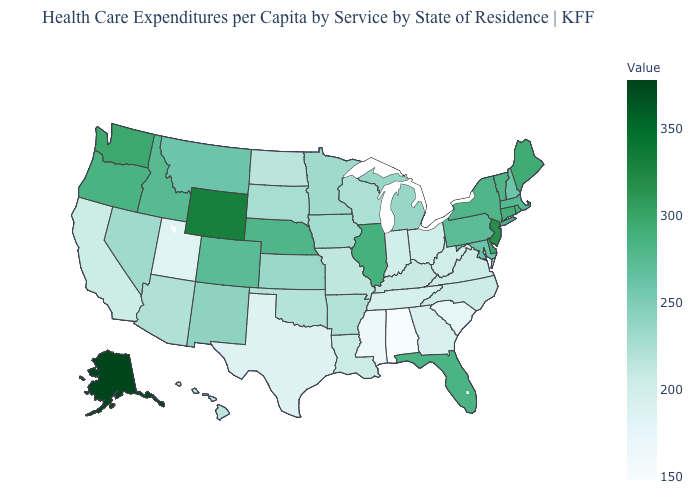Which states have the lowest value in the USA?
Short answer required. Alabama. Which states hav the highest value in the MidWest?
Keep it brief. Illinois. Among the states that border Delaware , which have the highest value?
Give a very brief answer. New Jersey. Which states have the highest value in the USA?
Concise answer only. Alaska. Among the states that border Arizona , does Utah have the highest value?
Give a very brief answer. No. Does Tennessee have a higher value than Mississippi?
Keep it brief. Yes. Among the states that border Nebraska , which have the highest value?
Quick response, please. Wyoming. Among the states that border New Hampshire , does Massachusetts have the highest value?
Write a very short answer. No. 